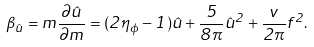Convert formula to latex. <formula><loc_0><loc_0><loc_500><loc_500>\beta _ { \hat { u } } = m \frac { \partial \hat { u } } { \partial m } = ( 2 \eta _ { \phi } - 1 ) \hat { u } + \frac { 5 } { 8 \pi } \hat { u } ^ { 2 } + \frac { v } { 2 \pi } f ^ { 2 } .</formula> 